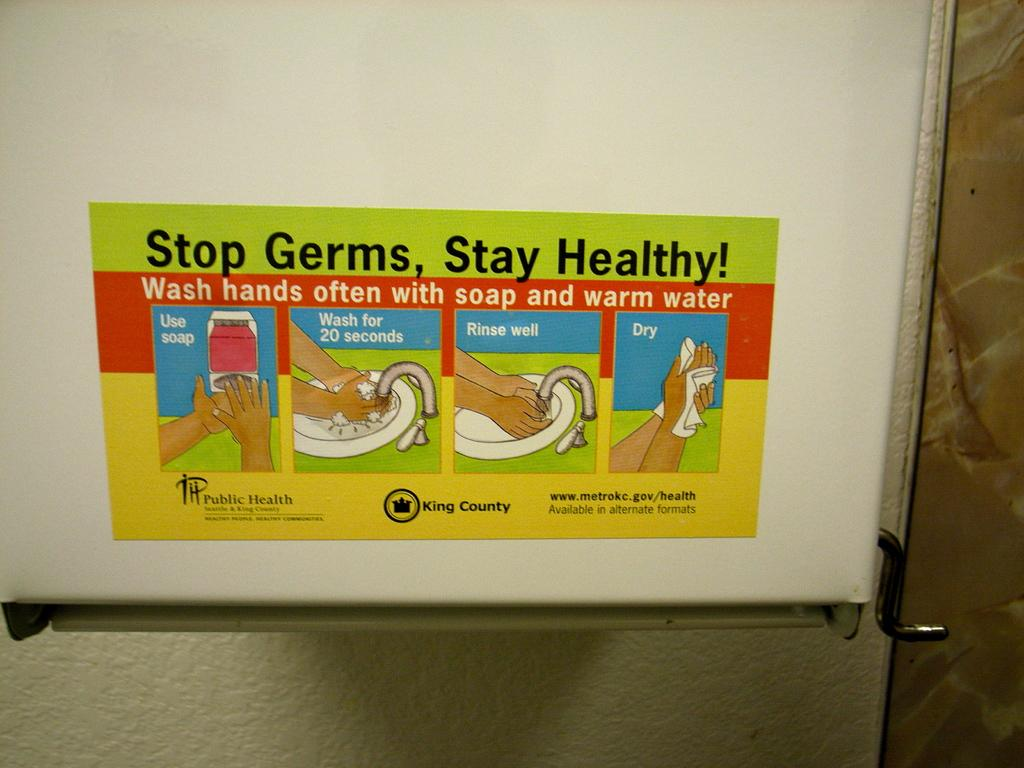Can you confirm if there is a door in the image? There might be a door in the image. What is on the door if it is present? There is a poster on the door. What can be read on the poster? There is text on the poster. What can be seen near the door? There is a sink in the image. Whose hand is visible in the image? A person's hand is visible in the image. What type of powder is being used by the person in the image? There is no indication of any powder being used in the image. 